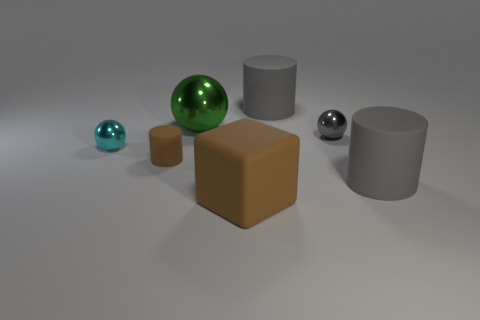What material is the small thing right of the cylinder behind the small brown thing made of? The small object to the right of the cylinder, located behind the small brown cube, appears to be made of a shiny metal with a reflective surface, suggesting it could be stainless steel or chrome-plated. 